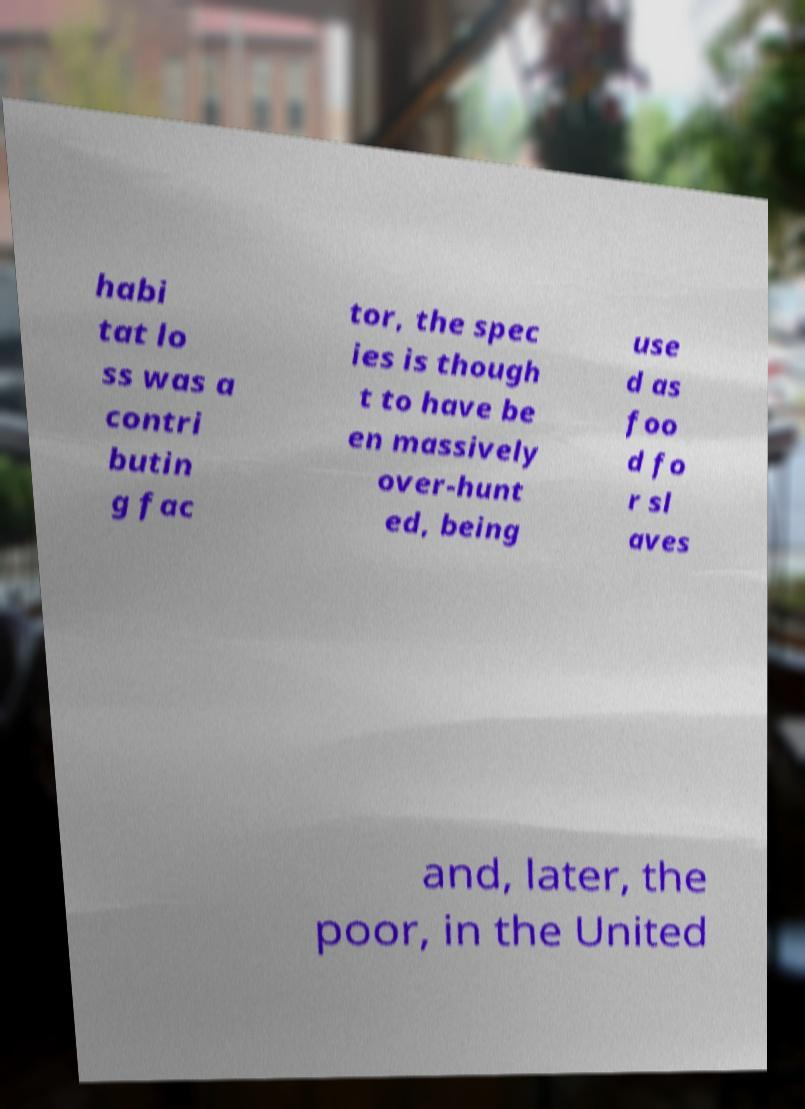Can you read and provide the text displayed in the image?This photo seems to have some interesting text. Can you extract and type it out for me? habi tat lo ss was a contri butin g fac tor, the spec ies is though t to have be en massively over-hunt ed, being use d as foo d fo r sl aves and, later, the poor, in the United 